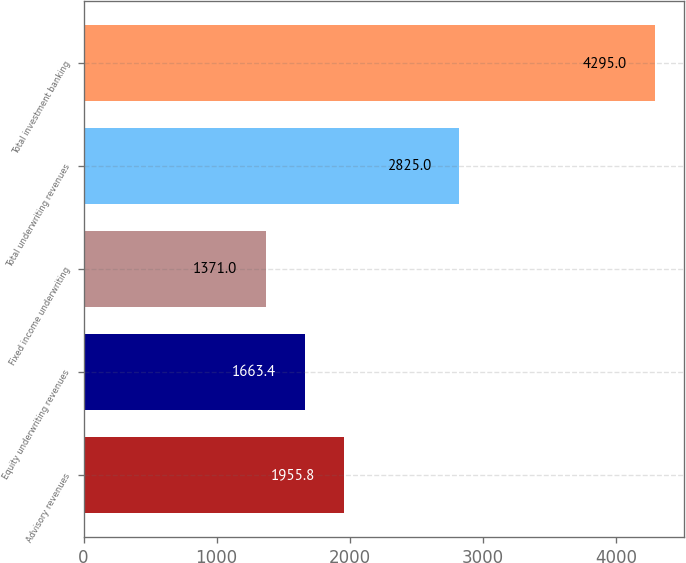<chart> <loc_0><loc_0><loc_500><loc_500><bar_chart><fcel>Advisory revenues<fcel>Equity underwriting revenues<fcel>Fixed income underwriting<fcel>Total underwriting revenues<fcel>Total investment banking<nl><fcel>1955.8<fcel>1663.4<fcel>1371<fcel>2825<fcel>4295<nl></chart> 